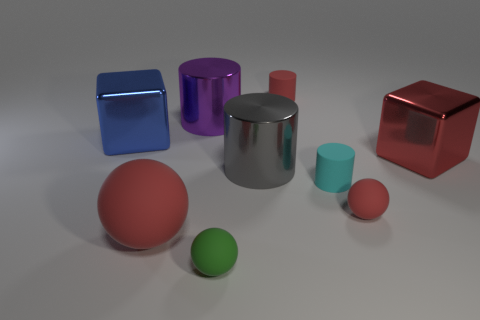Add 1 tiny matte balls. How many objects exist? 10 Subtract all cylinders. How many objects are left? 5 Subtract 1 red cylinders. How many objects are left? 8 Subtract all tiny yellow matte cylinders. Subtract all red cylinders. How many objects are left? 8 Add 2 red objects. How many red objects are left? 6 Add 8 large blue cylinders. How many large blue cylinders exist? 8 